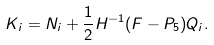Convert formula to latex. <formula><loc_0><loc_0><loc_500><loc_500>K _ { i } = N _ { i } + \frac { 1 } { 2 } H ^ { - 1 } ( F - P _ { 5 } ) Q _ { i } .</formula> 